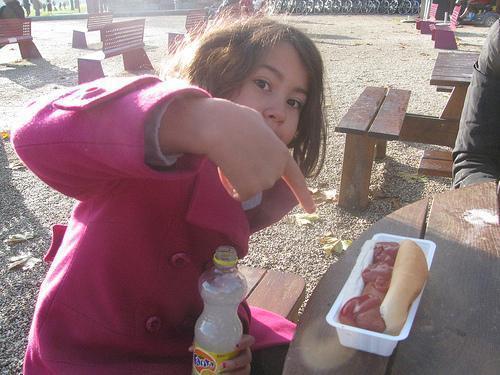How many kids are in this picture?
Give a very brief answer. 1. 